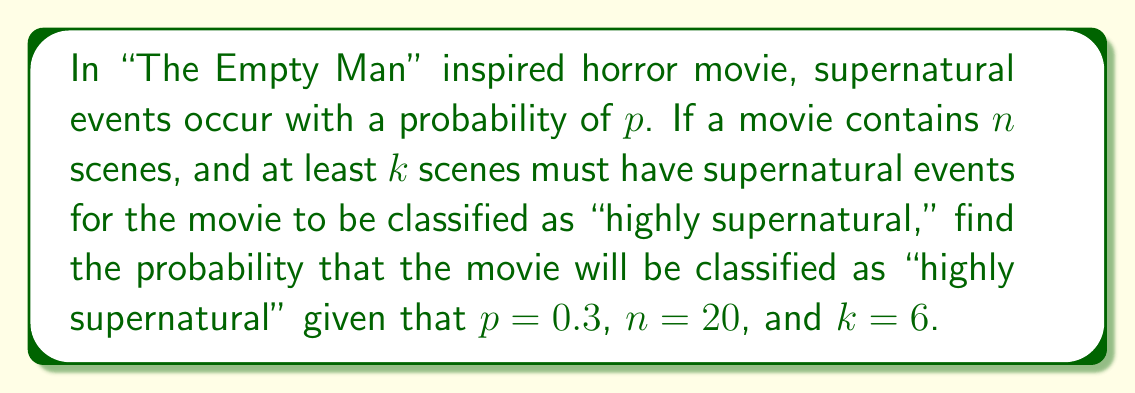Could you help me with this problem? To solve this problem, we need to use the binomial probability distribution:

1) The probability of exactly $x$ supernatural events in $n$ scenes is given by:

   $$P(X = x) = \binom{n}{x} p^x (1-p)^{n-x}$$

2) We want the probability of at least $k$ supernatural events, so we need to sum the probabilities from $k$ to $n$:

   $$P(X \geq k) = \sum_{x=k}^n \binom{n}{x} p^x (1-p)^{n-x}$$

3) Given: $p = 0.3$, $n = 20$, $k = 6$

4) Substituting these values:

   $$P(X \geq 6) = \sum_{x=6}^{20} \binom{20}{x} (0.3)^x (0.7)^{20-x}$$

5) This sum can be calculated using a computer or calculator. The result is approximately 0.7576.
Answer: $0.7576$ or $75.76\%$ 